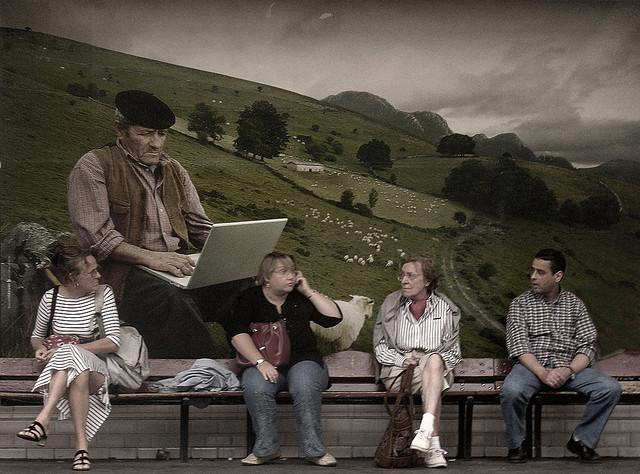What is the man in the mural using?

Choices:
A) toaster
B) laptop
C) phone
D) gun laptop 